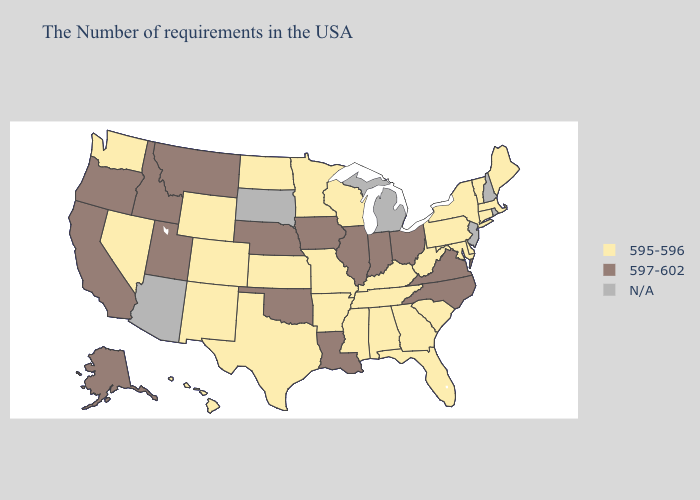What is the highest value in states that border Illinois?
Write a very short answer. 597-602. Does Arkansas have the highest value in the USA?
Short answer required. No. Among the states that border Illinois , does Indiana have the lowest value?
Concise answer only. No. Does Colorado have the lowest value in the West?
Quick response, please. Yes. Which states have the lowest value in the Northeast?
Write a very short answer. Maine, Massachusetts, Vermont, Connecticut, New York, Pennsylvania. What is the lowest value in states that border Mississippi?
Short answer required. 595-596. Which states have the highest value in the USA?
Keep it brief. Virginia, North Carolina, Ohio, Indiana, Illinois, Louisiana, Iowa, Nebraska, Oklahoma, Utah, Montana, Idaho, California, Oregon, Alaska. Name the states that have a value in the range 595-596?
Short answer required. Maine, Massachusetts, Vermont, Connecticut, New York, Delaware, Maryland, Pennsylvania, South Carolina, West Virginia, Florida, Georgia, Kentucky, Alabama, Tennessee, Wisconsin, Mississippi, Missouri, Arkansas, Minnesota, Kansas, Texas, North Dakota, Wyoming, Colorado, New Mexico, Nevada, Washington, Hawaii. What is the lowest value in the West?
Short answer required. 595-596. Name the states that have a value in the range N/A?
Concise answer only. Rhode Island, New Hampshire, New Jersey, Michigan, South Dakota, Arizona. Among the states that border Tennessee , which have the lowest value?
Be succinct. Georgia, Kentucky, Alabama, Mississippi, Missouri, Arkansas. What is the highest value in states that border Alabama?
Short answer required. 595-596. Which states hav the highest value in the South?
Short answer required. Virginia, North Carolina, Louisiana, Oklahoma. Does the map have missing data?
Short answer required. Yes. 